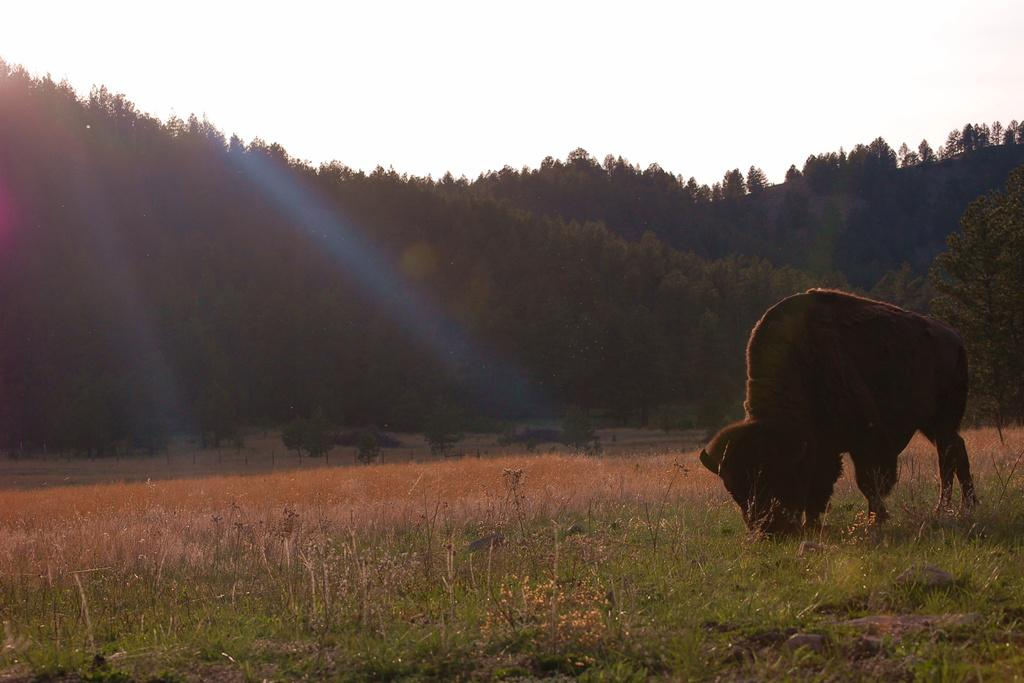What type of animal can be seen on the ground in the image? There is an animal on the ground in the image, but the specific type cannot be determined from the facts provided. What other natural elements are visible in the image? Plants, grass, and a group of trees are visible in the image. What is the condition of the sky in the image? The sky is visible in the image and appears cloudy. What type of clover is the cub chewing on in the image? There is no clover or cub present in the image. What is the minister doing in the image? There is no minister present in the image. 